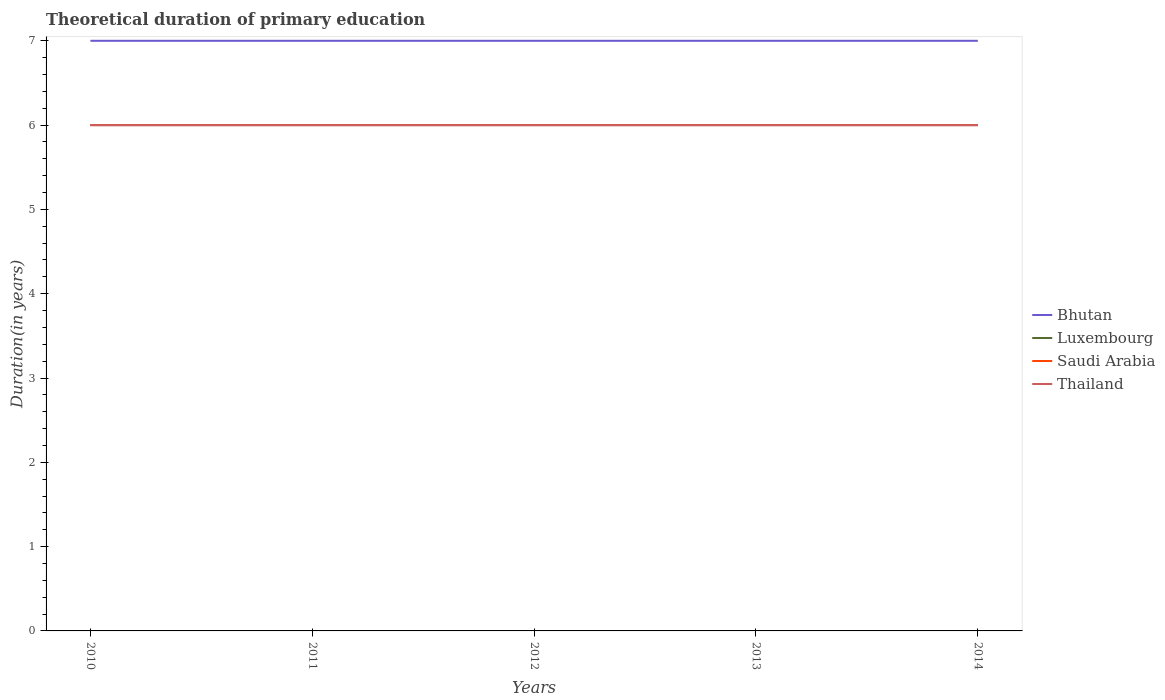Is the number of lines equal to the number of legend labels?
Keep it short and to the point. Yes. Across all years, what is the maximum total theoretical duration of primary education in Bhutan?
Ensure brevity in your answer.  7. What is the total total theoretical duration of primary education in Bhutan in the graph?
Offer a very short reply. 0. What is the difference between the highest and the second highest total theoretical duration of primary education in Bhutan?
Offer a very short reply. 0. How many legend labels are there?
Ensure brevity in your answer.  4. What is the title of the graph?
Your answer should be compact. Theoretical duration of primary education. What is the label or title of the Y-axis?
Give a very brief answer. Duration(in years). What is the Duration(in years) in Bhutan in 2010?
Offer a terse response. 7. What is the Duration(in years) of Luxembourg in 2010?
Your answer should be compact. 6. What is the Duration(in years) of Saudi Arabia in 2010?
Offer a very short reply. 6. What is the Duration(in years) of Luxembourg in 2011?
Provide a succinct answer. 6. What is the Duration(in years) in Saudi Arabia in 2011?
Make the answer very short. 6. What is the Duration(in years) in Thailand in 2011?
Offer a terse response. 6. What is the Duration(in years) in Luxembourg in 2012?
Keep it short and to the point. 6. What is the Duration(in years) in Saudi Arabia in 2012?
Ensure brevity in your answer.  6. What is the Duration(in years) in Thailand in 2012?
Make the answer very short. 6. What is the Duration(in years) in Bhutan in 2013?
Provide a short and direct response. 7. What is the Duration(in years) of Luxembourg in 2013?
Offer a very short reply. 6. What is the Duration(in years) of Saudi Arabia in 2013?
Your answer should be very brief. 6. What is the Duration(in years) in Thailand in 2013?
Ensure brevity in your answer.  6. What is the Duration(in years) in Bhutan in 2014?
Ensure brevity in your answer.  7. What is the Duration(in years) in Thailand in 2014?
Provide a succinct answer. 6. Across all years, what is the maximum Duration(in years) in Bhutan?
Your answer should be compact. 7. Across all years, what is the maximum Duration(in years) of Luxembourg?
Your answer should be very brief. 6. Across all years, what is the maximum Duration(in years) of Saudi Arabia?
Offer a very short reply. 6. Across all years, what is the minimum Duration(in years) in Bhutan?
Offer a terse response. 7. What is the total Duration(in years) of Bhutan in the graph?
Keep it short and to the point. 35. What is the total Duration(in years) in Thailand in the graph?
Give a very brief answer. 30. What is the difference between the Duration(in years) of Bhutan in 2010 and that in 2011?
Offer a very short reply. 0. What is the difference between the Duration(in years) in Saudi Arabia in 2010 and that in 2011?
Make the answer very short. 0. What is the difference between the Duration(in years) in Thailand in 2010 and that in 2012?
Make the answer very short. 0. What is the difference between the Duration(in years) of Luxembourg in 2010 and that in 2013?
Provide a succinct answer. 0. What is the difference between the Duration(in years) of Luxembourg in 2010 and that in 2014?
Provide a short and direct response. 0. What is the difference between the Duration(in years) of Saudi Arabia in 2010 and that in 2014?
Your answer should be very brief. 0. What is the difference between the Duration(in years) of Thailand in 2010 and that in 2014?
Your answer should be compact. 0. What is the difference between the Duration(in years) in Bhutan in 2011 and that in 2012?
Give a very brief answer. 0. What is the difference between the Duration(in years) in Bhutan in 2011 and that in 2013?
Make the answer very short. 0. What is the difference between the Duration(in years) in Thailand in 2011 and that in 2013?
Your response must be concise. 0. What is the difference between the Duration(in years) in Luxembourg in 2011 and that in 2014?
Offer a terse response. 0. What is the difference between the Duration(in years) in Thailand in 2011 and that in 2014?
Your answer should be compact. 0. What is the difference between the Duration(in years) in Saudi Arabia in 2012 and that in 2013?
Your answer should be compact. 0. What is the difference between the Duration(in years) in Thailand in 2012 and that in 2013?
Make the answer very short. 0. What is the difference between the Duration(in years) in Bhutan in 2012 and that in 2014?
Your response must be concise. 0. What is the difference between the Duration(in years) of Saudi Arabia in 2012 and that in 2014?
Your response must be concise. 0. What is the difference between the Duration(in years) in Bhutan in 2013 and that in 2014?
Provide a succinct answer. 0. What is the difference between the Duration(in years) in Luxembourg in 2013 and that in 2014?
Make the answer very short. 0. What is the difference between the Duration(in years) in Saudi Arabia in 2013 and that in 2014?
Your response must be concise. 0. What is the difference between the Duration(in years) in Bhutan in 2010 and the Duration(in years) in Luxembourg in 2011?
Keep it short and to the point. 1. What is the difference between the Duration(in years) in Bhutan in 2010 and the Duration(in years) in Saudi Arabia in 2011?
Offer a very short reply. 1. What is the difference between the Duration(in years) in Bhutan in 2010 and the Duration(in years) in Thailand in 2011?
Provide a short and direct response. 1. What is the difference between the Duration(in years) of Luxembourg in 2010 and the Duration(in years) of Saudi Arabia in 2011?
Keep it short and to the point. 0. What is the difference between the Duration(in years) of Luxembourg in 2010 and the Duration(in years) of Thailand in 2011?
Your response must be concise. 0. What is the difference between the Duration(in years) of Saudi Arabia in 2010 and the Duration(in years) of Thailand in 2011?
Your answer should be very brief. 0. What is the difference between the Duration(in years) of Bhutan in 2010 and the Duration(in years) of Luxembourg in 2012?
Keep it short and to the point. 1. What is the difference between the Duration(in years) of Bhutan in 2010 and the Duration(in years) of Saudi Arabia in 2012?
Your answer should be compact. 1. What is the difference between the Duration(in years) in Bhutan in 2010 and the Duration(in years) in Thailand in 2012?
Ensure brevity in your answer.  1. What is the difference between the Duration(in years) in Luxembourg in 2010 and the Duration(in years) in Saudi Arabia in 2012?
Your answer should be compact. 0. What is the difference between the Duration(in years) of Saudi Arabia in 2010 and the Duration(in years) of Thailand in 2012?
Your answer should be very brief. 0. What is the difference between the Duration(in years) of Bhutan in 2010 and the Duration(in years) of Saudi Arabia in 2013?
Provide a short and direct response. 1. What is the difference between the Duration(in years) in Bhutan in 2010 and the Duration(in years) in Thailand in 2013?
Offer a very short reply. 1. What is the difference between the Duration(in years) of Luxembourg in 2010 and the Duration(in years) of Thailand in 2013?
Give a very brief answer. 0. What is the difference between the Duration(in years) in Bhutan in 2010 and the Duration(in years) in Luxembourg in 2014?
Offer a terse response. 1. What is the difference between the Duration(in years) of Bhutan in 2010 and the Duration(in years) of Saudi Arabia in 2014?
Provide a short and direct response. 1. What is the difference between the Duration(in years) of Bhutan in 2010 and the Duration(in years) of Thailand in 2014?
Your answer should be very brief. 1. What is the difference between the Duration(in years) of Luxembourg in 2010 and the Duration(in years) of Thailand in 2014?
Offer a very short reply. 0. What is the difference between the Duration(in years) of Saudi Arabia in 2010 and the Duration(in years) of Thailand in 2014?
Keep it short and to the point. 0. What is the difference between the Duration(in years) of Luxembourg in 2011 and the Duration(in years) of Thailand in 2012?
Your answer should be compact. 0. What is the difference between the Duration(in years) in Luxembourg in 2011 and the Duration(in years) in Saudi Arabia in 2013?
Offer a terse response. 0. What is the difference between the Duration(in years) in Saudi Arabia in 2011 and the Duration(in years) in Thailand in 2013?
Ensure brevity in your answer.  0. What is the difference between the Duration(in years) of Bhutan in 2011 and the Duration(in years) of Luxembourg in 2014?
Your answer should be very brief. 1. What is the difference between the Duration(in years) of Luxembourg in 2011 and the Duration(in years) of Saudi Arabia in 2014?
Give a very brief answer. 0. What is the difference between the Duration(in years) in Luxembourg in 2011 and the Duration(in years) in Thailand in 2014?
Offer a terse response. 0. What is the difference between the Duration(in years) in Bhutan in 2012 and the Duration(in years) in Luxembourg in 2013?
Your answer should be compact. 1. What is the difference between the Duration(in years) of Bhutan in 2012 and the Duration(in years) of Saudi Arabia in 2013?
Your answer should be very brief. 1. What is the difference between the Duration(in years) in Luxembourg in 2012 and the Duration(in years) in Saudi Arabia in 2013?
Ensure brevity in your answer.  0. What is the difference between the Duration(in years) in Luxembourg in 2012 and the Duration(in years) in Saudi Arabia in 2014?
Provide a succinct answer. 0. What is the difference between the Duration(in years) of Saudi Arabia in 2012 and the Duration(in years) of Thailand in 2014?
Keep it short and to the point. 0. What is the difference between the Duration(in years) in Bhutan in 2013 and the Duration(in years) in Luxembourg in 2014?
Ensure brevity in your answer.  1. What is the average Duration(in years) of Bhutan per year?
Provide a succinct answer. 7. What is the average Duration(in years) of Luxembourg per year?
Offer a terse response. 6. What is the average Duration(in years) in Saudi Arabia per year?
Ensure brevity in your answer.  6. In the year 2010, what is the difference between the Duration(in years) in Luxembourg and Duration(in years) in Thailand?
Your response must be concise. 0. In the year 2010, what is the difference between the Duration(in years) in Saudi Arabia and Duration(in years) in Thailand?
Keep it short and to the point. 0. In the year 2011, what is the difference between the Duration(in years) of Bhutan and Duration(in years) of Saudi Arabia?
Make the answer very short. 1. In the year 2011, what is the difference between the Duration(in years) in Luxembourg and Duration(in years) in Saudi Arabia?
Your answer should be very brief. 0. In the year 2012, what is the difference between the Duration(in years) in Bhutan and Duration(in years) in Thailand?
Ensure brevity in your answer.  1. In the year 2013, what is the difference between the Duration(in years) of Bhutan and Duration(in years) of Saudi Arabia?
Your response must be concise. 1. In the year 2013, what is the difference between the Duration(in years) of Luxembourg and Duration(in years) of Thailand?
Offer a very short reply. 0. In the year 2013, what is the difference between the Duration(in years) of Saudi Arabia and Duration(in years) of Thailand?
Provide a short and direct response. 0. In the year 2014, what is the difference between the Duration(in years) in Bhutan and Duration(in years) in Luxembourg?
Offer a terse response. 1. In the year 2014, what is the difference between the Duration(in years) in Bhutan and Duration(in years) in Thailand?
Keep it short and to the point. 1. In the year 2014, what is the difference between the Duration(in years) in Luxembourg and Duration(in years) in Saudi Arabia?
Offer a terse response. 0. In the year 2014, what is the difference between the Duration(in years) of Saudi Arabia and Duration(in years) of Thailand?
Make the answer very short. 0. What is the ratio of the Duration(in years) in Bhutan in 2010 to that in 2011?
Your response must be concise. 1. What is the ratio of the Duration(in years) in Luxembourg in 2010 to that in 2011?
Give a very brief answer. 1. What is the ratio of the Duration(in years) in Thailand in 2010 to that in 2012?
Give a very brief answer. 1. What is the ratio of the Duration(in years) of Bhutan in 2010 to that in 2013?
Offer a terse response. 1. What is the ratio of the Duration(in years) in Luxembourg in 2010 to that in 2013?
Offer a very short reply. 1. What is the ratio of the Duration(in years) in Saudi Arabia in 2010 to that in 2013?
Make the answer very short. 1. What is the ratio of the Duration(in years) in Thailand in 2010 to that in 2013?
Offer a very short reply. 1. What is the ratio of the Duration(in years) in Luxembourg in 2010 to that in 2014?
Offer a terse response. 1. What is the ratio of the Duration(in years) in Thailand in 2010 to that in 2014?
Your answer should be very brief. 1. What is the ratio of the Duration(in years) of Bhutan in 2011 to that in 2013?
Offer a very short reply. 1. What is the ratio of the Duration(in years) of Saudi Arabia in 2011 to that in 2014?
Offer a very short reply. 1. What is the ratio of the Duration(in years) in Bhutan in 2012 to that in 2013?
Your answer should be compact. 1. What is the ratio of the Duration(in years) of Saudi Arabia in 2012 to that in 2013?
Offer a very short reply. 1. What is the ratio of the Duration(in years) in Luxembourg in 2012 to that in 2014?
Your answer should be compact. 1. What is the difference between the highest and the second highest Duration(in years) in Bhutan?
Ensure brevity in your answer.  0. What is the difference between the highest and the second highest Duration(in years) in Saudi Arabia?
Your response must be concise. 0. What is the difference between the highest and the lowest Duration(in years) of Bhutan?
Ensure brevity in your answer.  0. What is the difference between the highest and the lowest Duration(in years) in Luxembourg?
Your response must be concise. 0. What is the difference between the highest and the lowest Duration(in years) of Thailand?
Provide a succinct answer. 0. 